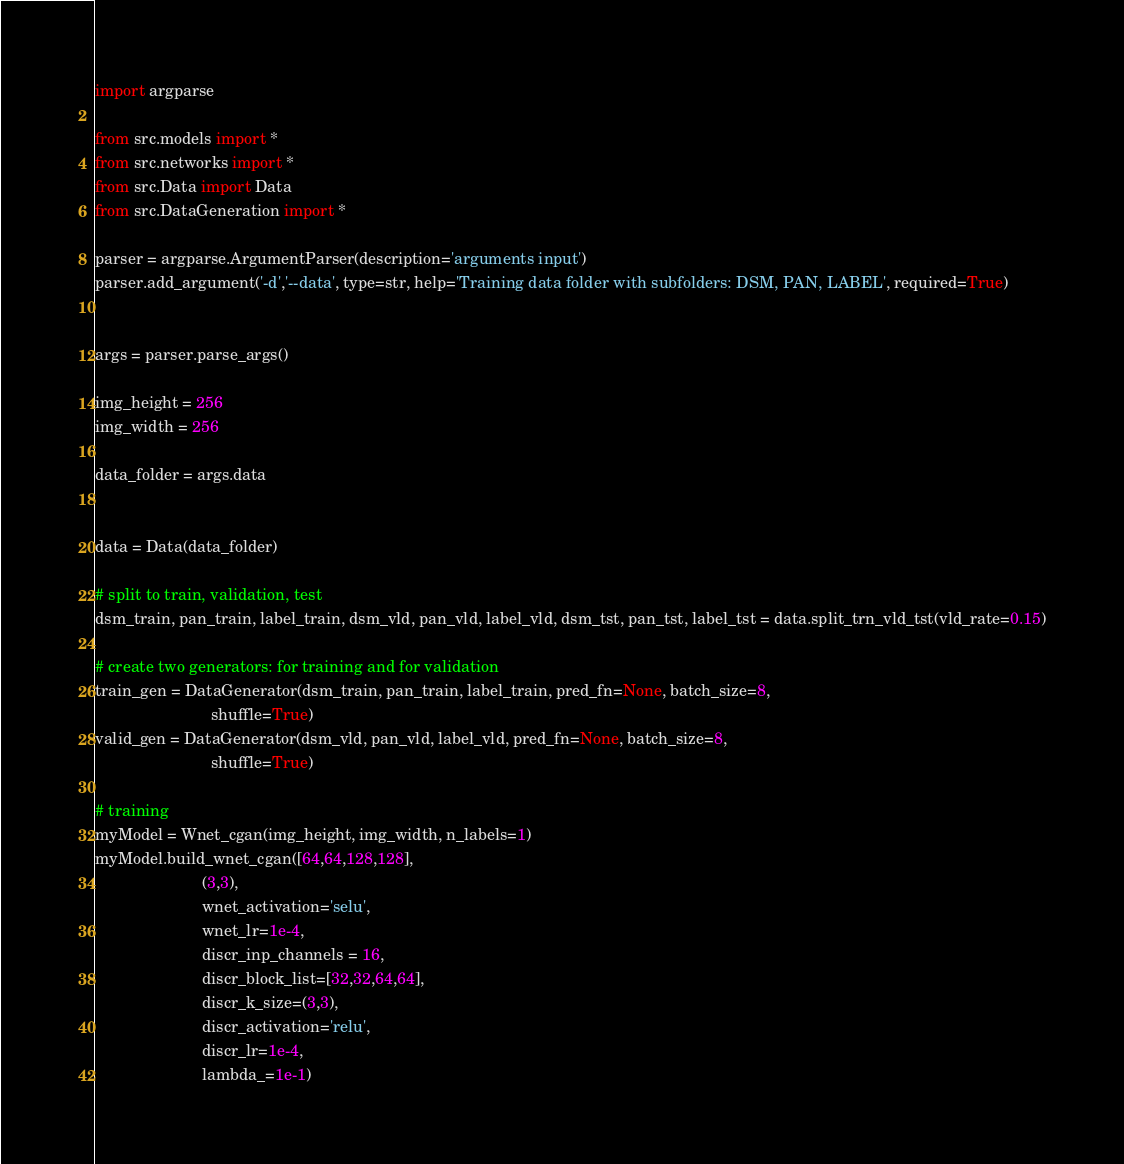<code> <loc_0><loc_0><loc_500><loc_500><_Python_>import argparse

from src.models import *
from src.networks import *
from src.Data import Data
from src.DataGeneration import *

parser = argparse.ArgumentParser(description='arguments input')
parser.add_argument('-d','--data', type=str, help='Training data folder with subfolders: DSM, PAN, LABEL', required=True)


args = parser.parse_args()

img_height = 256
img_width = 256

data_folder = args.data


data = Data(data_folder)

# split to train, validation, test
dsm_train, pan_train, label_train, dsm_vld, pan_vld, label_vld, dsm_tst, pan_tst, label_tst = data.split_trn_vld_tst(vld_rate=0.15)

# create two generators: for training and for validation
train_gen = DataGenerator(dsm_train, pan_train, label_train, pred_fn=None, batch_size=8, 
                          shuffle=True)
valid_gen = DataGenerator(dsm_vld, pan_vld, label_vld, pred_fn=None, batch_size=8, 
                          shuffle=True)

# training
myModel = Wnet_cgan(img_height, img_width, n_labels=1)
myModel.build_wnet_cgan([64,64,128,128],
                        (3,3), 
                        wnet_activation='selu',
                        wnet_lr=1e-4,
                        discr_inp_channels = 16,
                        discr_block_list=[32,32,64,64],
                        discr_k_size=(3,3), 
                        discr_activation='relu',
                        discr_lr=1e-4,
                        lambda_=1e-1)
</code> 